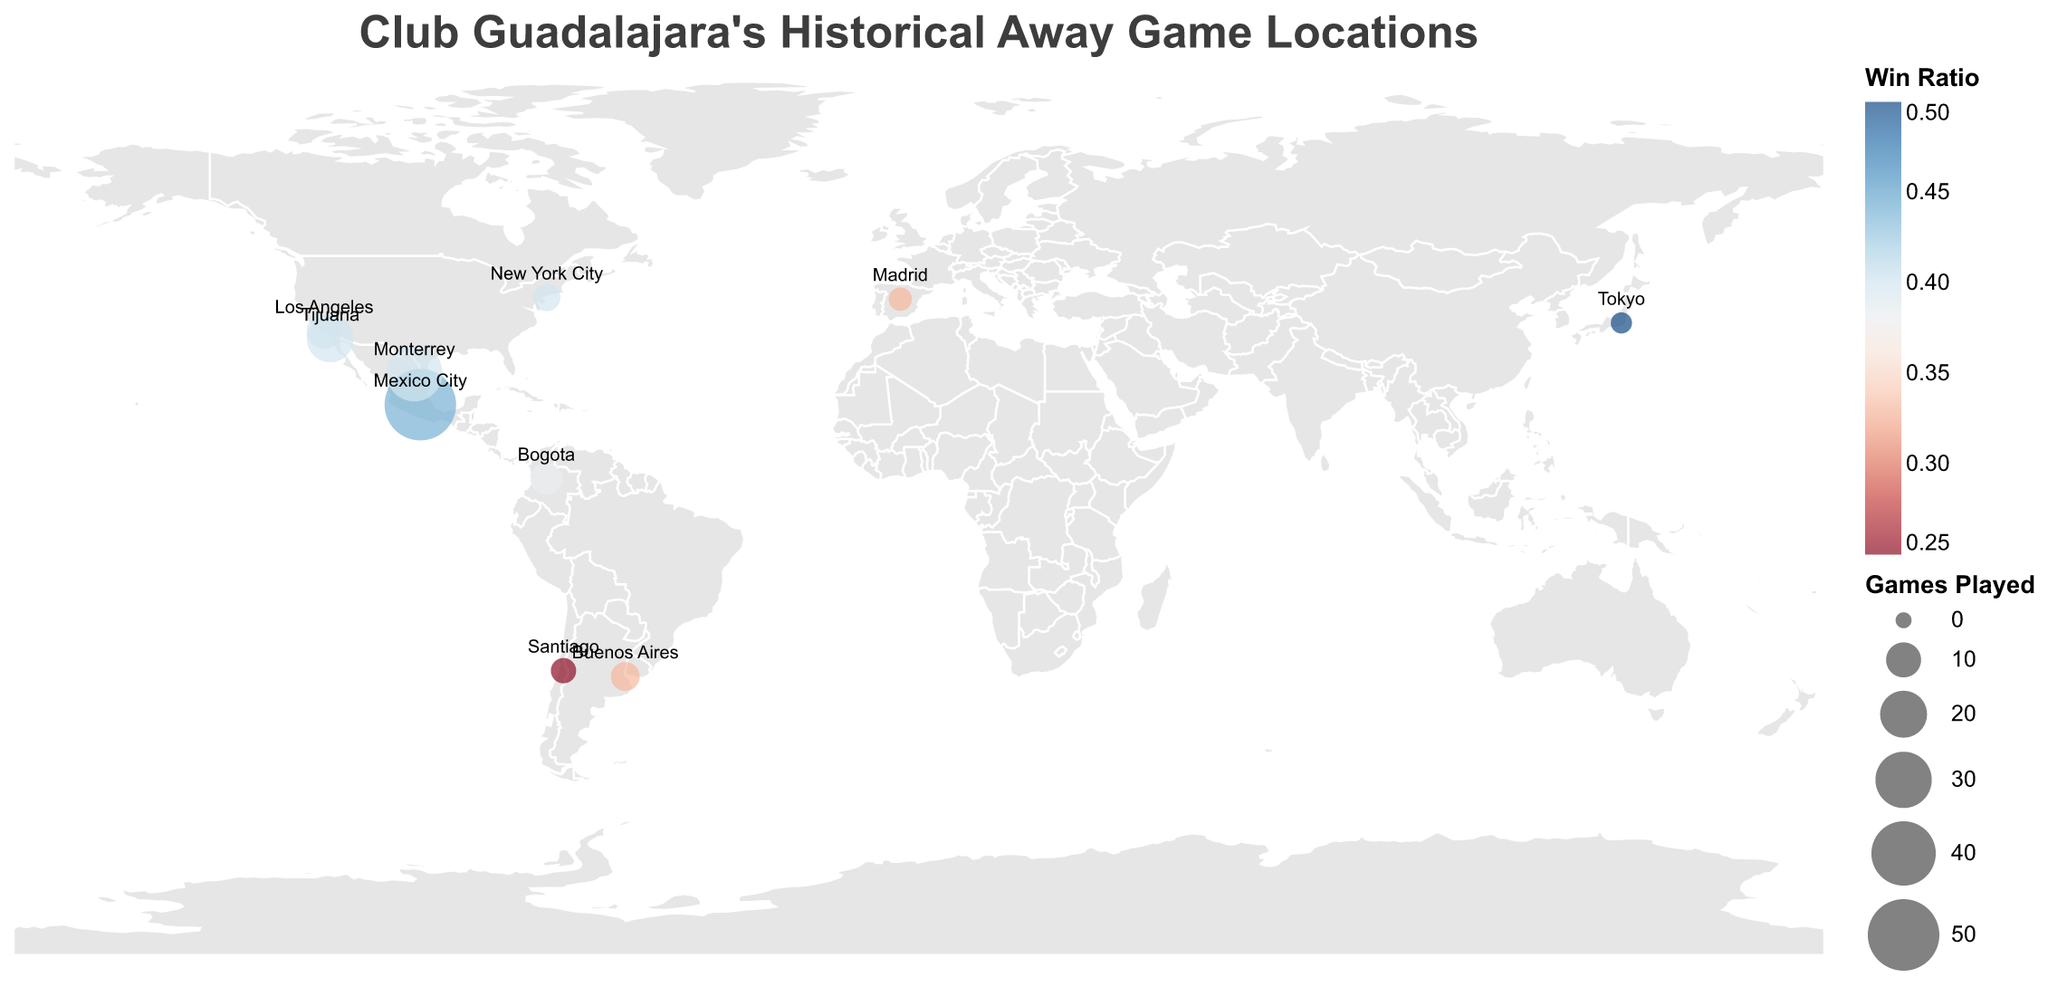What is the title of the map? The text at the top of the figure states the title. "Club Guadalajara's Historical Away Game Locations" is written clearly at the top.
Answer: Club Guadalajara's Historical Away Game Locations Which city has the highest win ratio? By examining the color coding and the values of the win ratios, Tokyo has the highest win ratio of 0.50.
Answer: Tokyo Which city has the highest number of games played? The size of the circle represents the number of games played. Mexico City has the largest circle, indicating 50 games played.
Answer: Mexico City What is the win ratio in Buenos Aires? Looking at the circle for Buenos Aires and referring to the tooltip or color legend, the win ratio is 0.33.
Answer: 0.33 Which city in Mexico has the lowest win ratio and what is it? By comparing the win ratios of Mexico City, Monterrey, and Tijuana from the color and data, Tijuana has the lowest win ratio of 0.40.
Answer: Tijuana, 0.40 How many cities have a win ratio of 0.40? By counting the cities with a win ratio of 0.40 from the data or color legend, there are 4 cities: Monterrey, Tijuana, Los Angeles, and New York City.
Answer: 4 What is the combined number of wins in Santiago and Tokyo? Summing the wins of Santiago (1) and Tokyo (1) from the data table or tooltips. The total is 1 + 1 = 2.
Answer: 2 Which country outside of Mexico has the most game locations and how many? Counting the cities by country outside Mexico, the USA has Los Angeles and New York City, totaling 2 cities.
Answer: USA, 2 In which hemisphere do most of the away games take place? By observing the geographic locations, most cities are in the Northern Hemisphere (Mexico City, Monterrey, Tijuana, Los Angeles, New York City, Bogota, Tokyo, Madrid).
Answer: Northern Hemisphere What is the average win ratio for the cities in the USA? The win ratios for Los Angeles (0.40) and New York City (0.40), calculating the average: (0.40 + 0.40) / 2 = 0.40.
Answer: 0.40 